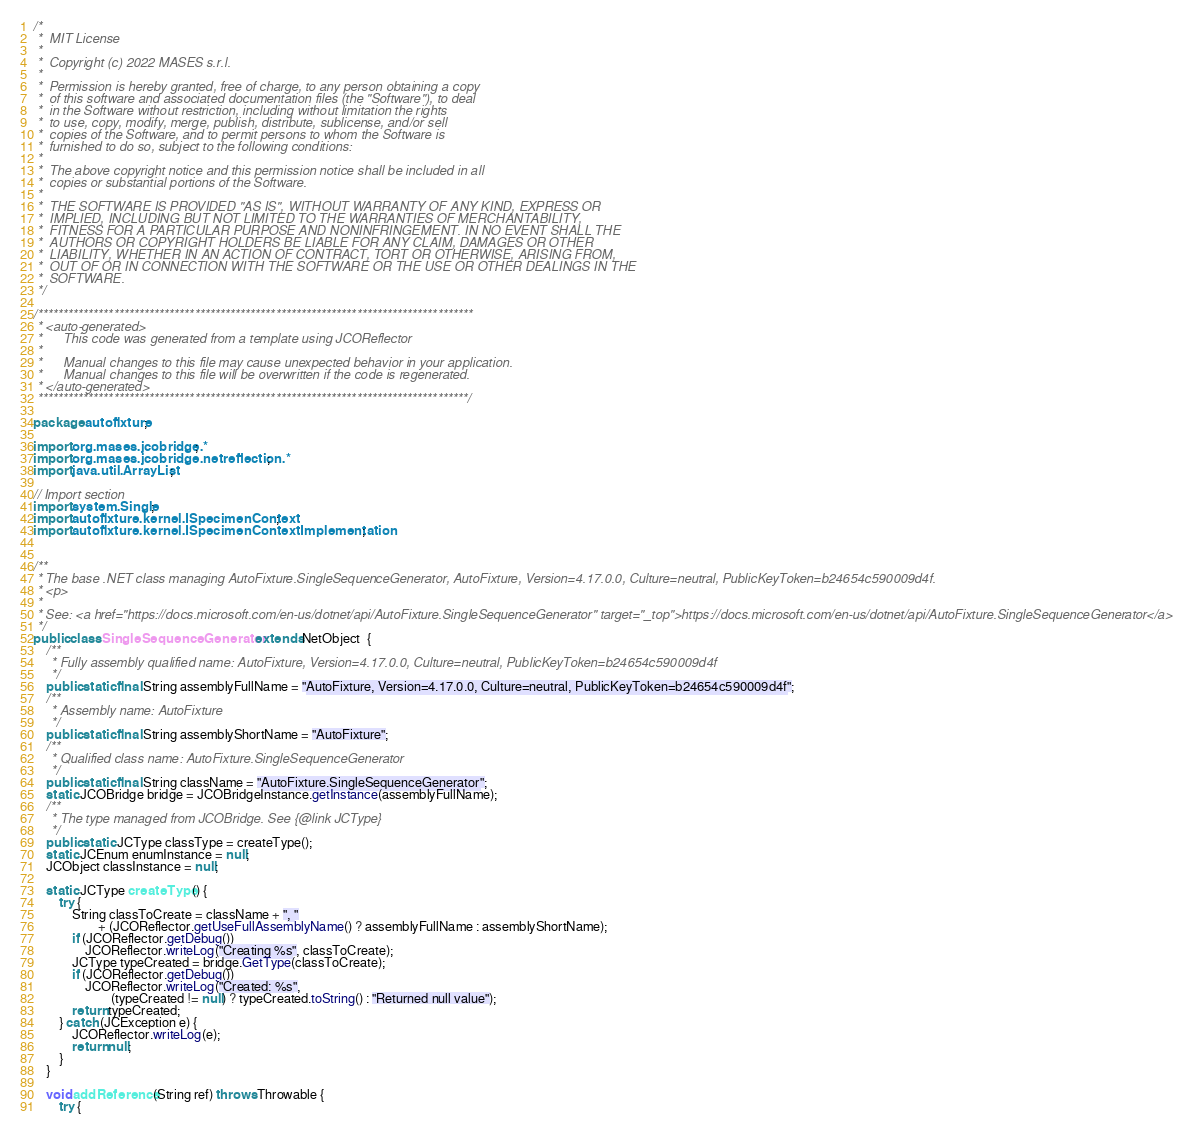<code> <loc_0><loc_0><loc_500><loc_500><_Java_>/*
 *  MIT License
 *
 *  Copyright (c) 2022 MASES s.r.l.
 *
 *  Permission is hereby granted, free of charge, to any person obtaining a copy
 *  of this software and associated documentation files (the "Software"), to deal
 *  in the Software without restriction, including without limitation the rights
 *  to use, copy, modify, merge, publish, distribute, sublicense, and/or sell
 *  copies of the Software, and to permit persons to whom the Software is
 *  furnished to do so, subject to the following conditions:
 *
 *  The above copyright notice and this permission notice shall be included in all
 *  copies or substantial portions of the Software.
 *
 *  THE SOFTWARE IS PROVIDED "AS IS", WITHOUT WARRANTY OF ANY KIND, EXPRESS OR
 *  IMPLIED, INCLUDING BUT NOT LIMITED TO THE WARRANTIES OF MERCHANTABILITY,
 *  FITNESS FOR A PARTICULAR PURPOSE AND NONINFRINGEMENT. IN NO EVENT SHALL THE
 *  AUTHORS OR COPYRIGHT HOLDERS BE LIABLE FOR ANY CLAIM, DAMAGES OR OTHER
 *  LIABILITY, WHETHER IN AN ACTION OF CONTRACT, TORT OR OTHERWISE, ARISING FROM,
 *  OUT OF OR IN CONNECTION WITH THE SOFTWARE OR THE USE OR OTHER DEALINGS IN THE
 *  SOFTWARE.
 */

/**************************************************************************************
 * <auto-generated>
 *      This code was generated from a template using JCOReflector
 * 
 *      Manual changes to this file may cause unexpected behavior in your application.
 *      Manual changes to this file will be overwritten if the code is regenerated.
 * </auto-generated>
 *************************************************************************************/

package autofixture;

import org.mases.jcobridge.*;
import org.mases.jcobridge.netreflection.*;
import java.util.ArrayList;

// Import section
import system.Single;
import autofixture.kernel.ISpecimenContext;
import autofixture.kernel.ISpecimenContextImplementation;


/**
 * The base .NET class managing AutoFixture.SingleSequenceGenerator, AutoFixture, Version=4.17.0.0, Culture=neutral, PublicKeyToken=b24654c590009d4f.
 * <p>
 * 
 * See: <a href="https://docs.microsoft.com/en-us/dotnet/api/AutoFixture.SingleSequenceGenerator" target="_top">https://docs.microsoft.com/en-us/dotnet/api/AutoFixture.SingleSequenceGenerator</a>
 */
public class SingleSequenceGenerator extends NetObject  {
    /**
     * Fully assembly qualified name: AutoFixture, Version=4.17.0.0, Culture=neutral, PublicKeyToken=b24654c590009d4f
     */
    public static final String assemblyFullName = "AutoFixture, Version=4.17.0.0, Culture=neutral, PublicKeyToken=b24654c590009d4f";
    /**
     * Assembly name: AutoFixture
     */
    public static final String assemblyShortName = "AutoFixture";
    /**
     * Qualified class name: AutoFixture.SingleSequenceGenerator
     */
    public static final String className = "AutoFixture.SingleSequenceGenerator";
    static JCOBridge bridge = JCOBridgeInstance.getInstance(assemblyFullName);
    /**
     * The type managed from JCOBridge. See {@link JCType}
     */
    public static JCType classType = createType();
    static JCEnum enumInstance = null;
    JCObject classInstance = null;

    static JCType createType() {
        try {
            String classToCreate = className + ", "
                    + (JCOReflector.getUseFullAssemblyName() ? assemblyFullName : assemblyShortName);
            if (JCOReflector.getDebug())
                JCOReflector.writeLog("Creating %s", classToCreate);
            JCType typeCreated = bridge.GetType(classToCreate);
            if (JCOReflector.getDebug())
                JCOReflector.writeLog("Created: %s",
                        (typeCreated != null) ? typeCreated.toString() : "Returned null value");
            return typeCreated;
        } catch (JCException e) {
            JCOReflector.writeLog(e);
            return null;
        }
    }

    void addReference(String ref) throws Throwable {
        try {</code> 